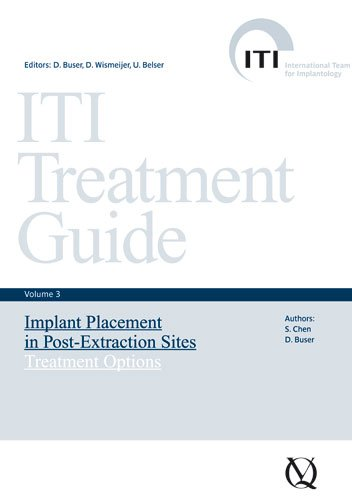Is this a kids book? No, this book is clearly intended for medical professionals, particularly those specializing in dental implants and is not suitable for children. 